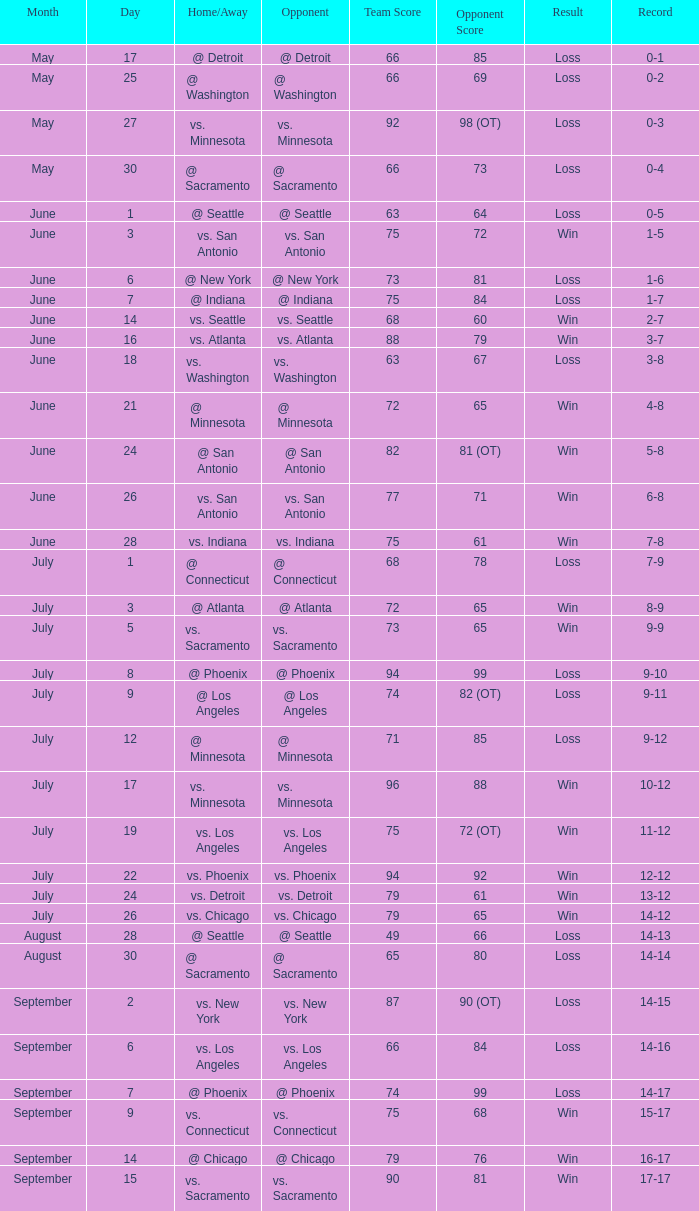Could you parse the entire table as a dict? {'header': ['Month', 'Day', 'Home/Away', 'Opponent', 'Team Score', 'Opponent Score', 'Result', 'Record'], 'rows': [['May', '17', '@ Detroit', '@ Detroit', '66', '85', 'Loss', '0-1'], ['May', '25', '@ Washington', '@ Washington', '66', '69', 'Loss', '0-2'], ['May', '27', 'vs. Minnesota', 'vs. Minnesota', '92', '98 (OT)', 'Loss', '0-3'], ['May', '30', '@ Sacramento', '@ Sacramento', '66', '73', 'Loss', '0-4'], ['June', '1', '@ Seattle', '@ Seattle', '63', '64', 'Loss', '0-5'], ['June', '3', 'vs. San Antonio', 'vs. San Antonio', '75', '72', 'Win', '1-5'], ['June', '6', '@ New York', '@ New York', '73', '81', 'Loss', '1-6'], ['June', '7', '@ Indiana', '@ Indiana', '75', '84', 'Loss', '1-7'], ['June', '14', 'vs. Seattle', 'vs. Seattle', '68', '60', 'Win', '2-7'], ['June', '16', 'vs. Atlanta', 'vs. Atlanta', '88', '79', 'Win', '3-7'], ['June', '18', 'vs. Washington', 'vs. Washington', '63', '67', 'Loss', '3-8'], ['June', '21', '@ Minnesota', '@ Minnesota', '72', '65', 'Win', '4-8'], ['June', '24', '@ San Antonio', '@ San Antonio', '82', '81 (OT)', 'Win', '5-8'], ['June', '26', 'vs. San Antonio', 'vs. San Antonio', '77', '71', 'Win', '6-8'], ['June', '28', 'vs. Indiana', 'vs. Indiana', '75', '61', 'Win', '7-8'], ['July', '1', '@ Connecticut', '@ Connecticut', '68', '78', 'Loss', '7-9'], ['July', '3', '@ Atlanta', '@ Atlanta', '72', '65', 'Win', '8-9'], ['July', '5', 'vs. Sacramento', 'vs. Sacramento', '73', '65', 'Win', '9-9'], ['July', '8', '@ Phoenix', '@ Phoenix', '94', '99', 'Loss', '9-10'], ['July', '9', '@ Los Angeles', '@ Los Angeles', '74', '82 (OT)', 'Loss', '9-11'], ['July', '12', '@ Minnesota', '@ Minnesota', '71', '85', 'Loss', '9-12'], ['July', '17', 'vs. Minnesota', 'vs. Minnesota', '96', '88', 'Win', '10-12'], ['July', '19', 'vs. Los Angeles', 'vs. Los Angeles', '75', '72 (OT)', 'Win', '11-12'], ['July', '22', 'vs. Phoenix', 'vs. Phoenix', '94', '92', 'Win', '12-12'], ['July', '24', 'vs. Detroit', 'vs. Detroit', '79', '61', 'Win', '13-12'], ['July', '26', 'vs. Chicago', 'vs. Chicago', '79', '65', 'Win', '14-12'], ['August', '28', '@ Seattle', '@ Seattle', '49', '66', 'Loss', '14-13'], ['August', '30', '@ Sacramento', '@ Sacramento', '65', '80', 'Loss', '14-14'], ['September', '2', 'vs. New York', 'vs. New York', '87', '90 (OT)', 'Loss', '14-15'], ['September', '6', 'vs. Los Angeles', 'vs. Los Angeles', '66', '84', 'Loss', '14-16'], ['September', '7', '@ Phoenix', '@ Phoenix', '74', '99', 'Loss', '14-17'], ['September', '9', 'vs. Connecticut', 'vs. Connecticut', '75', '68', 'Win', '15-17'], ['September', '14', '@ Chicago', '@ Chicago', '79', '76', 'Win', '16-17'], ['September', '15', 'vs. Sacramento', 'vs. Sacramento', '90', '81', 'Win', '17-17']]} What is the date of the match where there was a loss and the record stood at 7-9? July 1. 